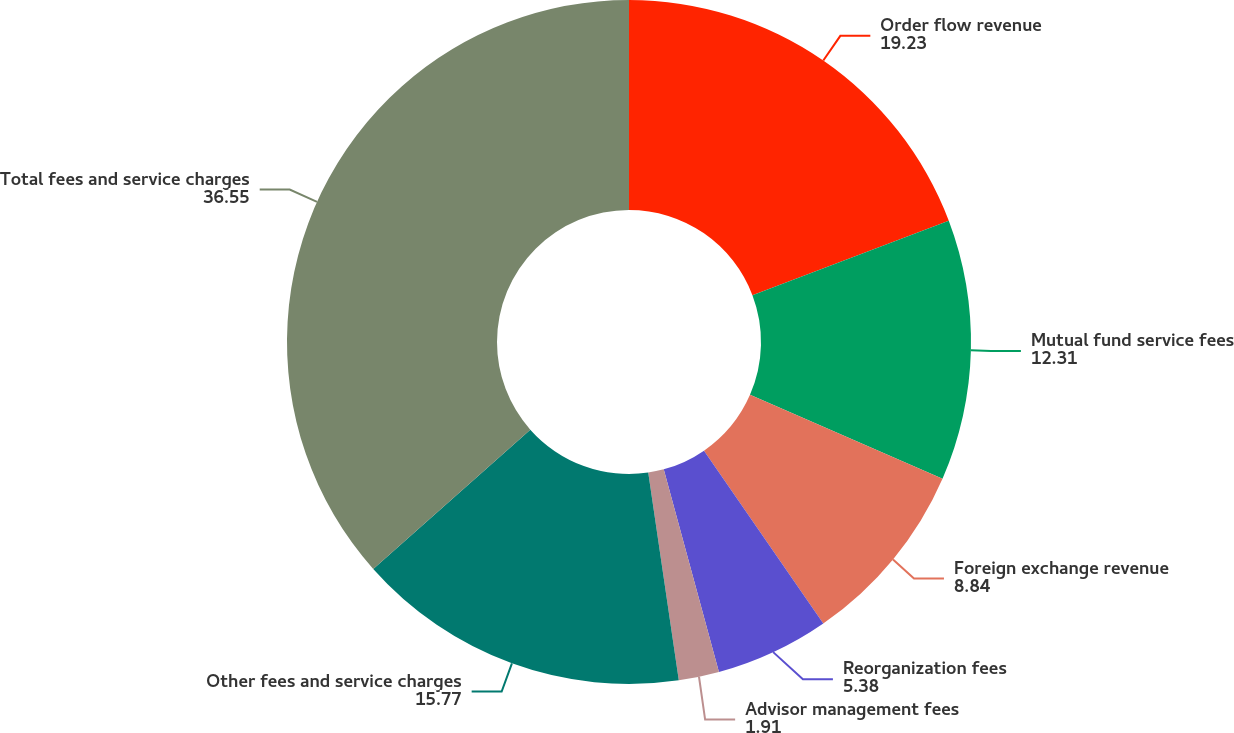<chart> <loc_0><loc_0><loc_500><loc_500><pie_chart><fcel>Order flow revenue<fcel>Mutual fund service fees<fcel>Foreign exchange revenue<fcel>Reorganization fees<fcel>Advisor management fees<fcel>Other fees and service charges<fcel>Total fees and service charges<nl><fcel>19.23%<fcel>12.31%<fcel>8.84%<fcel>5.38%<fcel>1.91%<fcel>15.77%<fcel>36.55%<nl></chart> 